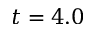<formula> <loc_0><loc_0><loc_500><loc_500>t = 4 . 0</formula> 